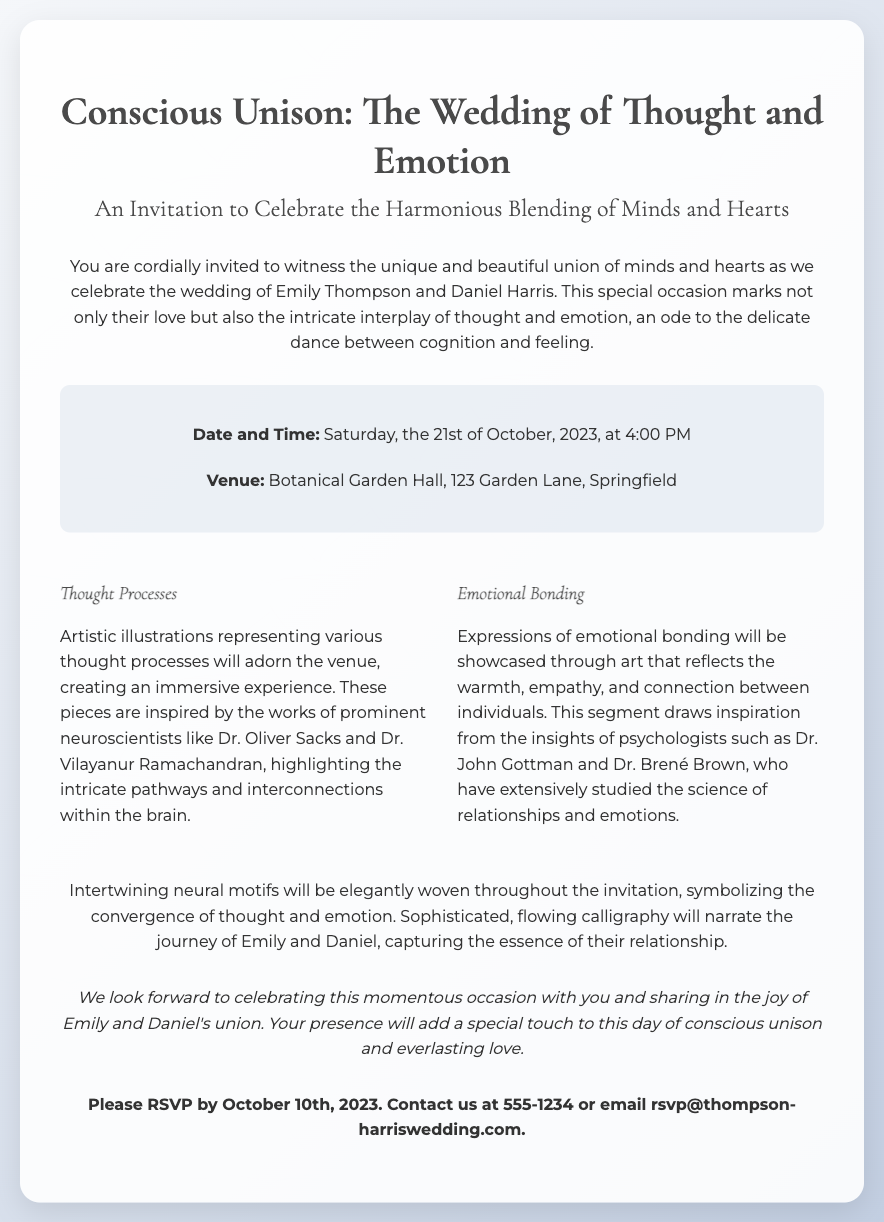What is the date of the wedding? The date of the wedding is mentioned in the details section of the invitation as Saturday, the 21st of October, 2023.
Answer: 21st of October, 2023 Who are the couple getting married? The couple getting married are introduced in the invitation as Emily Thompson and Daniel Harris.
Answer: Emily Thompson and Daniel Harris What venue will the wedding take place? The venue for the wedding is stated in the details section as Botanical Garden Hall, 123 Garden Lane, Springfield.
Answer: Botanical Garden Hall, 123 Garden Lane, Springfield What artistic theme is represented at the wedding? The invitation highlights the artistic theme of thought processes and emotional bonding which are central to the celebration.
Answer: Thought processes and emotional bonding What is the RSVP deadline? The RSVP deadline is specifically mentioned at the end of the invitation.
Answer: October 10th, 2023 Who inspired the artistic illustrations of thought processes? The invitation references prominent neuroscientists who inspired the artistic illustrations as Dr. Oliver Sacks and Dr. Vilayanur Ramachandran.
Answer: Dr. Oliver Sacks and Dr. Vilayanur Ramachandran What type of motifs are woven throughout the invitation? The motifs mentioned in the invitation symbolize the convergence of thought and emotion.
Answer: Intertwining neural motifs What is the tone of the closing statement? The closing statement expresses anticipation and joy regarding the wedding celebration.
Answer: Joyful anticipation 